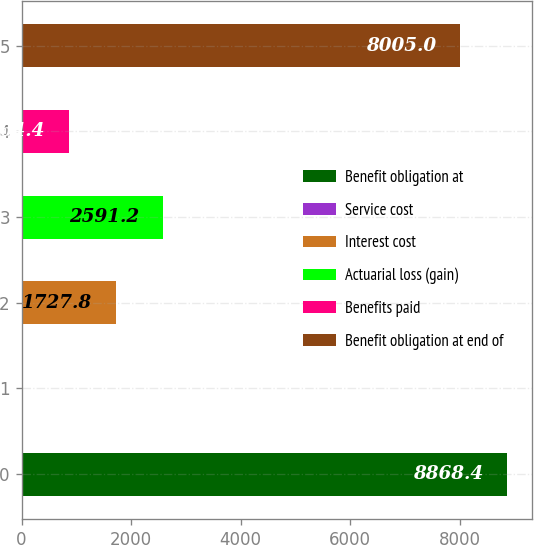Convert chart to OTSL. <chart><loc_0><loc_0><loc_500><loc_500><bar_chart><fcel>Benefit obligation at<fcel>Service cost<fcel>Interest cost<fcel>Actuarial loss (gain)<fcel>Benefits paid<fcel>Benefit obligation at end of<nl><fcel>8868.4<fcel>1<fcel>1727.8<fcel>2591.2<fcel>864.4<fcel>8005<nl></chart> 